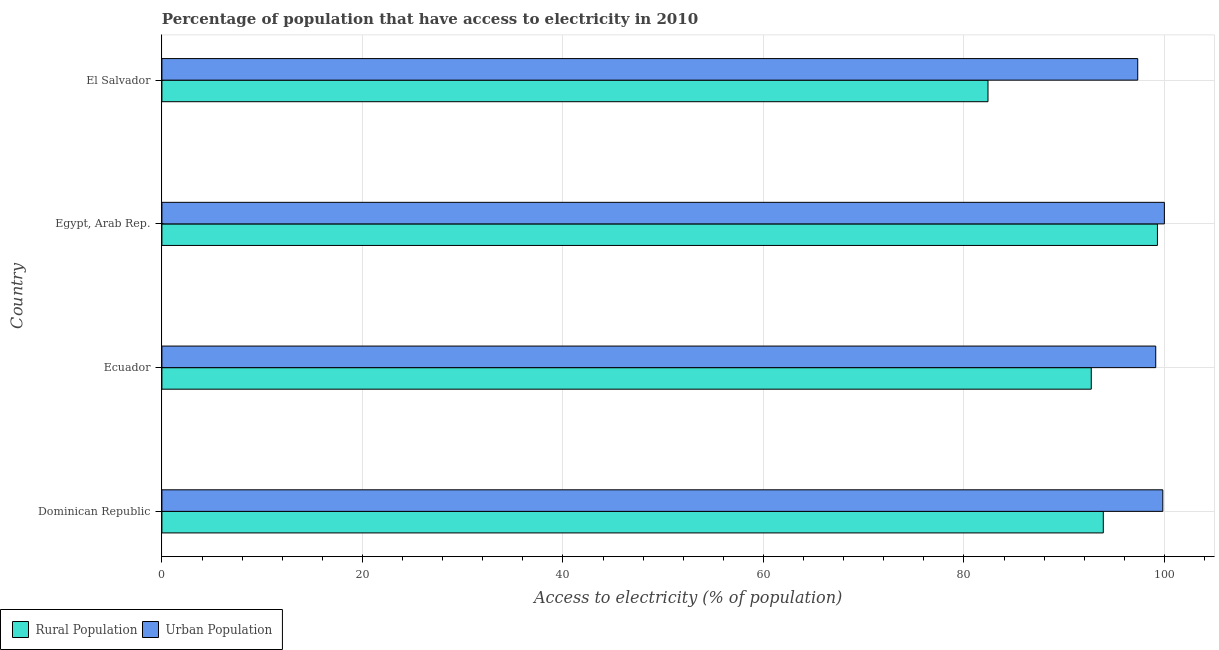How many groups of bars are there?
Give a very brief answer. 4. What is the label of the 4th group of bars from the top?
Make the answer very short. Dominican Republic. In how many cases, is the number of bars for a given country not equal to the number of legend labels?
Your response must be concise. 0. What is the percentage of rural population having access to electricity in El Salvador?
Provide a short and direct response. 82.4. Across all countries, what is the maximum percentage of urban population having access to electricity?
Keep it short and to the point. 99.99. Across all countries, what is the minimum percentage of rural population having access to electricity?
Make the answer very short. 82.4. In which country was the percentage of urban population having access to electricity maximum?
Ensure brevity in your answer.  Egypt, Arab Rep. In which country was the percentage of rural population having access to electricity minimum?
Your answer should be compact. El Salvador. What is the total percentage of urban population having access to electricity in the graph?
Offer a very short reply. 396.29. What is the difference between the percentage of rural population having access to electricity in Dominican Republic and the percentage of urban population having access to electricity in El Salvador?
Make the answer very short. -3.43. What is the average percentage of rural population having access to electricity per country?
Make the answer very short. 92.08. What is the difference between the percentage of urban population having access to electricity and percentage of rural population having access to electricity in Ecuador?
Provide a short and direct response. 6.43. What is the ratio of the percentage of urban population having access to electricity in Dominican Republic to that in Egypt, Arab Rep.?
Give a very brief answer. 1. Is the percentage of rural population having access to electricity in Dominican Republic less than that in Ecuador?
Keep it short and to the point. No. Is the difference between the percentage of rural population having access to electricity in Dominican Republic and El Salvador greater than the difference between the percentage of urban population having access to electricity in Dominican Republic and El Salvador?
Provide a succinct answer. Yes. What is the difference between the highest and the second highest percentage of urban population having access to electricity?
Ensure brevity in your answer.  0.16. In how many countries, is the percentage of rural population having access to electricity greater than the average percentage of rural population having access to electricity taken over all countries?
Provide a succinct answer. 3. What does the 2nd bar from the top in Ecuador represents?
Your answer should be very brief. Rural Population. What does the 2nd bar from the bottom in Egypt, Arab Rep. represents?
Ensure brevity in your answer.  Urban Population. How many bars are there?
Give a very brief answer. 8. Are all the bars in the graph horizontal?
Make the answer very short. Yes. How many countries are there in the graph?
Your answer should be compact. 4. What is the difference between two consecutive major ticks on the X-axis?
Keep it short and to the point. 20. Are the values on the major ticks of X-axis written in scientific E-notation?
Ensure brevity in your answer.  No. Does the graph contain grids?
Provide a succinct answer. Yes. How many legend labels are there?
Make the answer very short. 2. How are the legend labels stacked?
Your answer should be compact. Horizontal. What is the title of the graph?
Offer a terse response. Percentage of population that have access to electricity in 2010. What is the label or title of the X-axis?
Your answer should be compact. Access to electricity (% of population). What is the Access to electricity (% of population) of Rural Population in Dominican Republic?
Your response must be concise. 93.9. What is the Access to electricity (% of population) of Urban Population in Dominican Republic?
Your answer should be compact. 99.84. What is the Access to electricity (% of population) in Rural Population in Ecuador?
Keep it short and to the point. 92.7. What is the Access to electricity (% of population) of Urban Population in Ecuador?
Your response must be concise. 99.13. What is the Access to electricity (% of population) in Rural Population in Egypt, Arab Rep.?
Give a very brief answer. 99.3. What is the Access to electricity (% of population) of Urban Population in Egypt, Arab Rep.?
Offer a terse response. 99.99. What is the Access to electricity (% of population) in Rural Population in El Salvador?
Offer a terse response. 82.4. What is the Access to electricity (% of population) in Urban Population in El Salvador?
Offer a terse response. 97.33. Across all countries, what is the maximum Access to electricity (% of population) in Rural Population?
Offer a very short reply. 99.3. Across all countries, what is the maximum Access to electricity (% of population) of Urban Population?
Your answer should be compact. 99.99. Across all countries, what is the minimum Access to electricity (% of population) of Rural Population?
Your answer should be compact. 82.4. Across all countries, what is the minimum Access to electricity (% of population) of Urban Population?
Provide a short and direct response. 97.33. What is the total Access to electricity (% of population) in Rural Population in the graph?
Your answer should be compact. 368.3. What is the total Access to electricity (% of population) of Urban Population in the graph?
Make the answer very short. 396.29. What is the difference between the Access to electricity (% of population) in Urban Population in Dominican Republic and that in Ecuador?
Give a very brief answer. 0.7. What is the difference between the Access to electricity (% of population) in Rural Population in Dominican Republic and that in Egypt, Arab Rep.?
Your answer should be compact. -5.4. What is the difference between the Access to electricity (% of population) in Urban Population in Dominican Republic and that in Egypt, Arab Rep.?
Offer a very short reply. -0.16. What is the difference between the Access to electricity (% of population) of Urban Population in Dominican Republic and that in El Salvador?
Make the answer very short. 2.5. What is the difference between the Access to electricity (% of population) in Rural Population in Ecuador and that in Egypt, Arab Rep.?
Keep it short and to the point. -6.6. What is the difference between the Access to electricity (% of population) in Urban Population in Ecuador and that in Egypt, Arab Rep.?
Offer a terse response. -0.86. What is the difference between the Access to electricity (% of population) in Urban Population in Ecuador and that in El Salvador?
Provide a succinct answer. 1.8. What is the difference between the Access to electricity (% of population) in Urban Population in Egypt, Arab Rep. and that in El Salvador?
Ensure brevity in your answer.  2.66. What is the difference between the Access to electricity (% of population) in Rural Population in Dominican Republic and the Access to electricity (% of population) in Urban Population in Ecuador?
Your answer should be very brief. -5.23. What is the difference between the Access to electricity (% of population) of Rural Population in Dominican Republic and the Access to electricity (% of population) of Urban Population in Egypt, Arab Rep.?
Offer a terse response. -6.09. What is the difference between the Access to electricity (% of population) in Rural Population in Dominican Republic and the Access to electricity (% of population) in Urban Population in El Salvador?
Offer a terse response. -3.43. What is the difference between the Access to electricity (% of population) of Rural Population in Ecuador and the Access to electricity (% of population) of Urban Population in Egypt, Arab Rep.?
Offer a very short reply. -7.29. What is the difference between the Access to electricity (% of population) in Rural Population in Ecuador and the Access to electricity (% of population) in Urban Population in El Salvador?
Offer a terse response. -4.63. What is the difference between the Access to electricity (% of population) of Rural Population in Egypt, Arab Rep. and the Access to electricity (% of population) of Urban Population in El Salvador?
Ensure brevity in your answer.  1.97. What is the average Access to electricity (% of population) of Rural Population per country?
Your response must be concise. 92.08. What is the average Access to electricity (% of population) of Urban Population per country?
Ensure brevity in your answer.  99.07. What is the difference between the Access to electricity (% of population) in Rural Population and Access to electricity (% of population) in Urban Population in Dominican Republic?
Offer a very short reply. -5.94. What is the difference between the Access to electricity (% of population) of Rural Population and Access to electricity (% of population) of Urban Population in Ecuador?
Provide a succinct answer. -6.43. What is the difference between the Access to electricity (% of population) in Rural Population and Access to electricity (% of population) in Urban Population in Egypt, Arab Rep.?
Your answer should be very brief. -0.69. What is the difference between the Access to electricity (% of population) in Rural Population and Access to electricity (% of population) in Urban Population in El Salvador?
Give a very brief answer. -14.93. What is the ratio of the Access to electricity (% of population) of Rural Population in Dominican Republic to that in Ecuador?
Ensure brevity in your answer.  1.01. What is the ratio of the Access to electricity (% of population) of Urban Population in Dominican Republic to that in Ecuador?
Provide a short and direct response. 1.01. What is the ratio of the Access to electricity (% of population) in Rural Population in Dominican Republic to that in Egypt, Arab Rep.?
Provide a succinct answer. 0.95. What is the ratio of the Access to electricity (% of population) in Rural Population in Dominican Republic to that in El Salvador?
Offer a very short reply. 1.14. What is the ratio of the Access to electricity (% of population) of Urban Population in Dominican Republic to that in El Salvador?
Ensure brevity in your answer.  1.03. What is the ratio of the Access to electricity (% of population) in Rural Population in Ecuador to that in Egypt, Arab Rep.?
Your answer should be compact. 0.93. What is the ratio of the Access to electricity (% of population) in Rural Population in Ecuador to that in El Salvador?
Ensure brevity in your answer.  1.12. What is the ratio of the Access to electricity (% of population) of Urban Population in Ecuador to that in El Salvador?
Your answer should be very brief. 1.02. What is the ratio of the Access to electricity (% of population) in Rural Population in Egypt, Arab Rep. to that in El Salvador?
Your answer should be compact. 1.21. What is the ratio of the Access to electricity (% of population) in Urban Population in Egypt, Arab Rep. to that in El Salvador?
Offer a terse response. 1.03. What is the difference between the highest and the second highest Access to electricity (% of population) in Urban Population?
Offer a very short reply. 0.16. What is the difference between the highest and the lowest Access to electricity (% of population) in Rural Population?
Your answer should be compact. 16.9. What is the difference between the highest and the lowest Access to electricity (% of population) of Urban Population?
Make the answer very short. 2.66. 